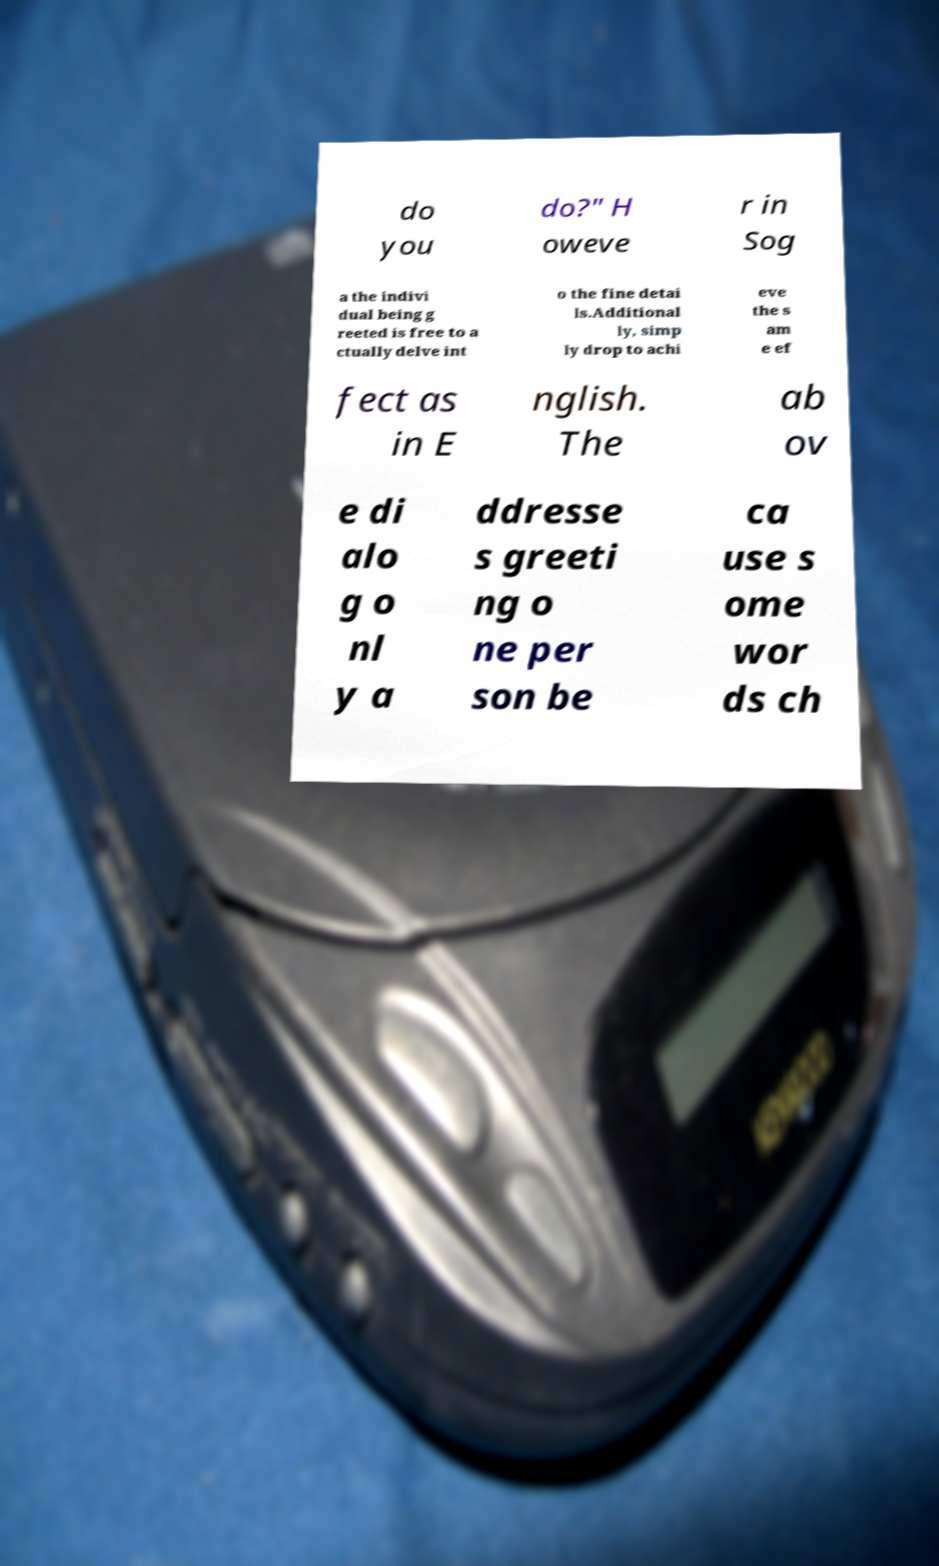For documentation purposes, I need the text within this image transcribed. Could you provide that? do you do?" H oweve r in Sog a the indivi dual being g reeted is free to a ctually delve int o the fine detai ls.Additional ly, simp ly drop to achi eve the s am e ef fect as in E nglish. The ab ov e di alo g o nl y a ddresse s greeti ng o ne per son be ca use s ome wor ds ch 